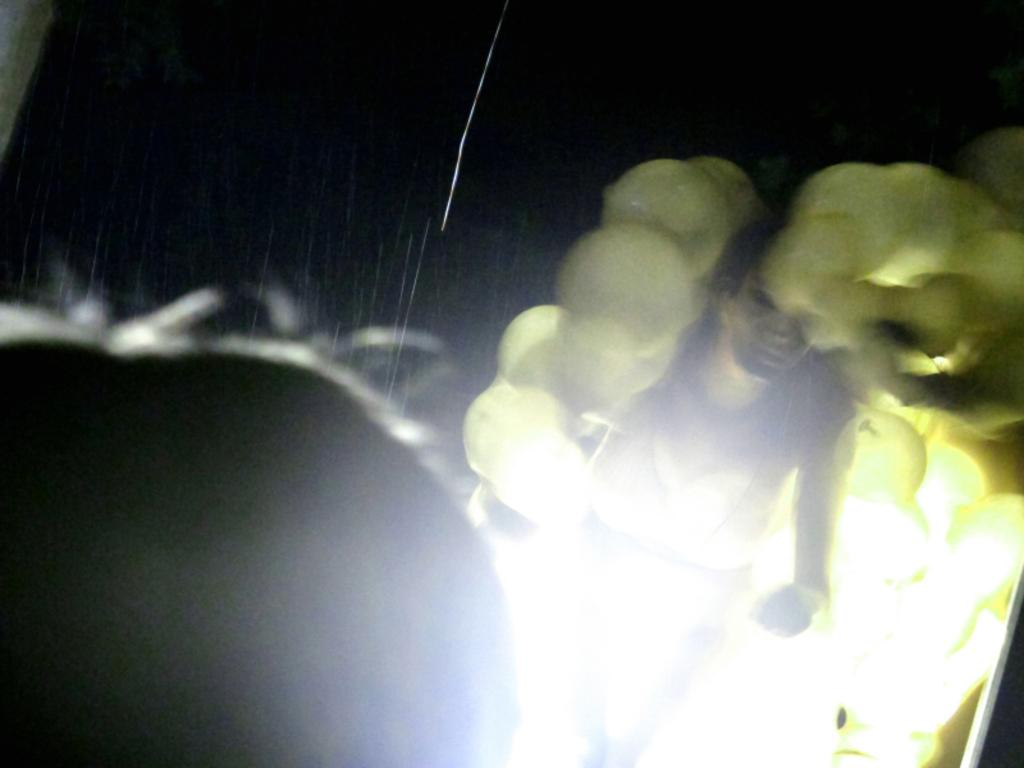What is the main subject of the image? There is a person in the image. Can you describe the person's surroundings? The person is between lights. How would you describe the quality of the image? The image is blurry. What can be observed about the background of the image? The background of the image is dark. What type of knot is the person tying in the image? There is no knot present in the image; the person is between lights. What downtown area is visible in the image? There is no downtown area visible in the image; the background is dark. 